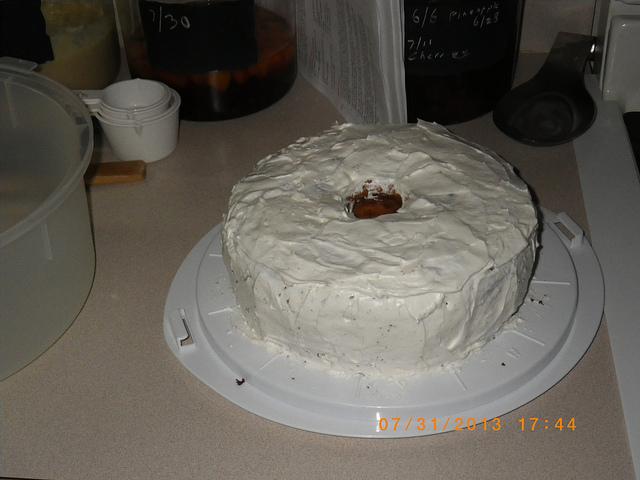Is there a serving spoon on the counter?
Answer briefly. No. Is this a kitchen appliance?
Write a very short answer. No. How many people do you see?
Answer briefly. 0. What kind of icing is on the cake?
Be succinct. Vanilla. Is it homemade or manufactured cake?
Keep it brief. Homemade. What colors are the cake?
Keep it brief. White. What color is the tablecloth?
Be succinct. White. Is this cake on a paper plate?
Short answer required. No. Is that a brownie or chocolate cake?
Answer briefly. Chocolate cake. What's to the left of the plate?
Write a very short answer. Lid. Is there anything been stirred?
Be succinct. No. What sort of object is this?
Be succinct. Cake. Is the cake round?
Be succinct. Yes. Is this a blender?
Concise answer only. No. What color is this object?
Give a very brief answer. White. 